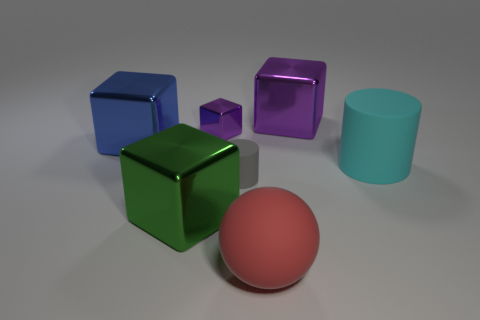Subtract all cyan cylinders. How many cylinders are left? 1 Subtract all big purple blocks. How many blocks are left? 3 Add 3 blue metal cylinders. How many objects exist? 10 Subtract 2 cubes. How many cubes are left? 2 Subtract all cylinders. How many objects are left? 5 Subtract all purple balls. How many yellow blocks are left? 0 Subtract all cyan cylinders. Subtract all cylinders. How many objects are left? 4 Add 4 metal objects. How many metal objects are left? 8 Add 5 rubber spheres. How many rubber spheres exist? 6 Subtract 0 purple balls. How many objects are left? 7 